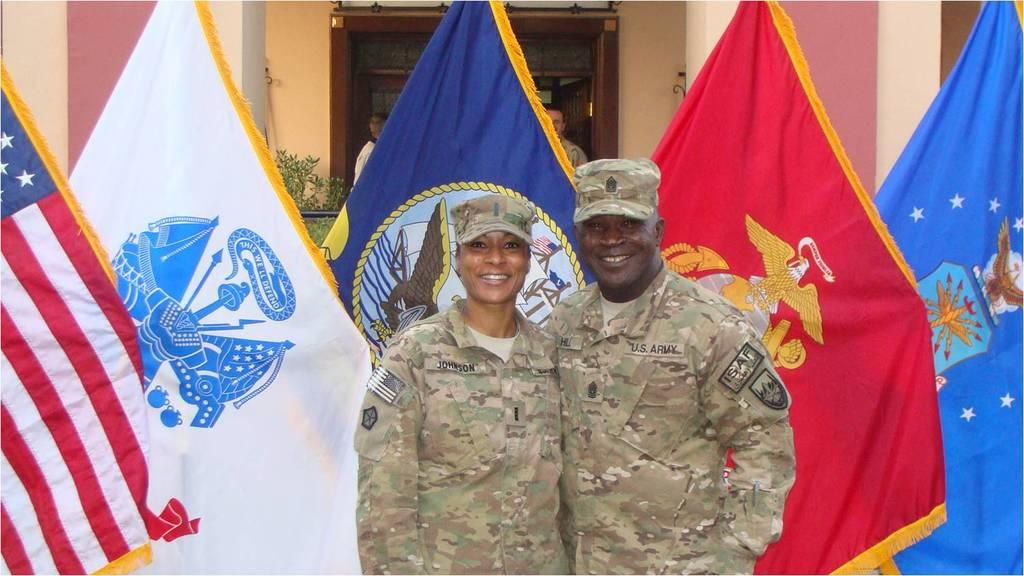What are the two persons in the image wearing? The two persons in the image are wearing military uniforms. What are the positions of the two persons in the image? The two persons are standing. What can be seen in the background of the image? There are flags, other persons, a plant, and a building in the background of the image. How much money is being exchanged between the two persons in the image? There is no indication of money being exchanged between the two persons in the image. 